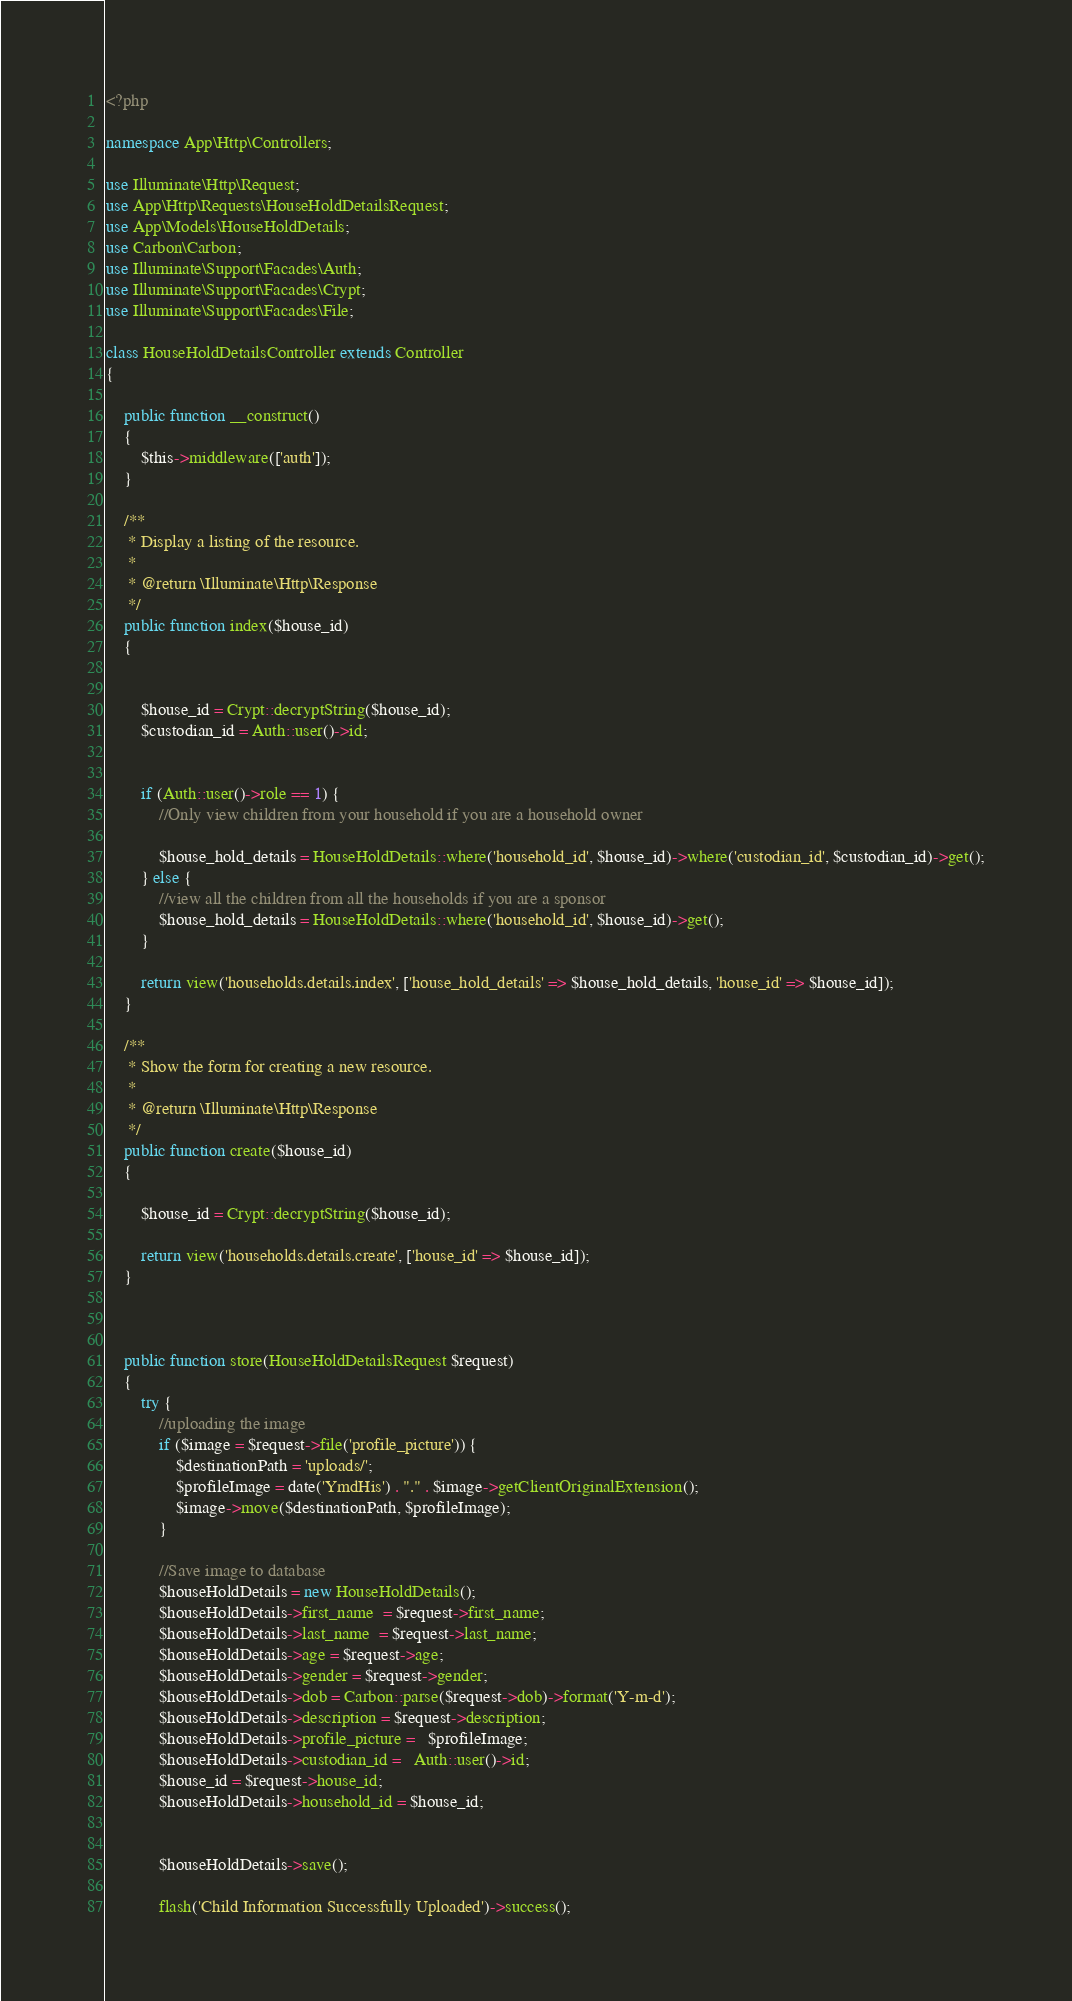<code> <loc_0><loc_0><loc_500><loc_500><_PHP_><?php

namespace App\Http\Controllers;

use Illuminate\Http\Request;
use App\Http\Requests\HouseHoldDetailsRequest;
use App\Models\HouseHoldDetails;
use Carbon\Carbon;
use Illuminate\Support\Facades\Auth;
use Illuminate\Support\Facades\Crypt;
use Illuminate\Support\Facades\File;

class HouseHoldDetailsController extends Controller
{

    public function __construct()
    {
        $this->middleware(['auth']);
    }

    /**
     * Display a listing of the resource.
     *
     * @return \Illuminate\Http\Response
     */
    public function index($house_id)
    {


        $house_id = Crypt::decryptString($house_id);
        $custodian_id = Auth::user()->id;


        if (Auth::user()->role == 1) {
            //Only view children from your household if you are a household owner

            $house_hold_details = HouseHoldDetails::where('household_id', $house_id)->where('custodian_id', $custodian_id)->get();
        } else {
            //view all the children from all the households if you are a sponsor
            $house_hold_details = HouseHoldDetails::where('household_id', $house_id)->get();
        }

        return view('households.details.index', ['house_hold_details' => $house_hold_details, 'house_id' => $house_id]);
    }

    /**
     * Show the form for creating a new resource.
     *
     * @return \Illuminate\Http\Response
     */
    public function create($house_id)
    {

        $house_id = Crypt::decryptString($house_id);

        return view('households.details.create', ['house_id' => $house_id]);
    }



    public function store(HouseHoldDetailsRequest $request)
    {
        try {
            //uploading the image
            if ($image = $request->file('profile_picture')) {
                $destinationPath = 'uploads/';
                $profileImage = date('YmdHis') . "." . $image->getClientOriginalExtension();
                $image->move($destinationPath, $profileImage);
            }

            //Save image to database
            $houseHoldDetails = new HouseHoldDetails();
            $houseHoldDetails->first_name  = $request->first_name;
            $houseHoldDetails->last_name  = $request->last_name;
            $houseHoldDetails->age = $request->age;
            $houseHoldDetails->gender = $request->gender;
            $houseHoldDetails->dob = Carbon::parse($request->dob)->format('Y-m-d');
            $houseHoldDetails->description = $request->description;
            $houseHoldDetails->profile_picture =   $profileImage;
            $houseHoldDetails->custodian_id =   Auth::user()->id;
            $house_id = $request->house_id;
            $houseHoldDetails->household_id = $house_id;


            $houseHoldDetails->save();

            flash('Child Information Successfully Uploaded')->success();</code> 